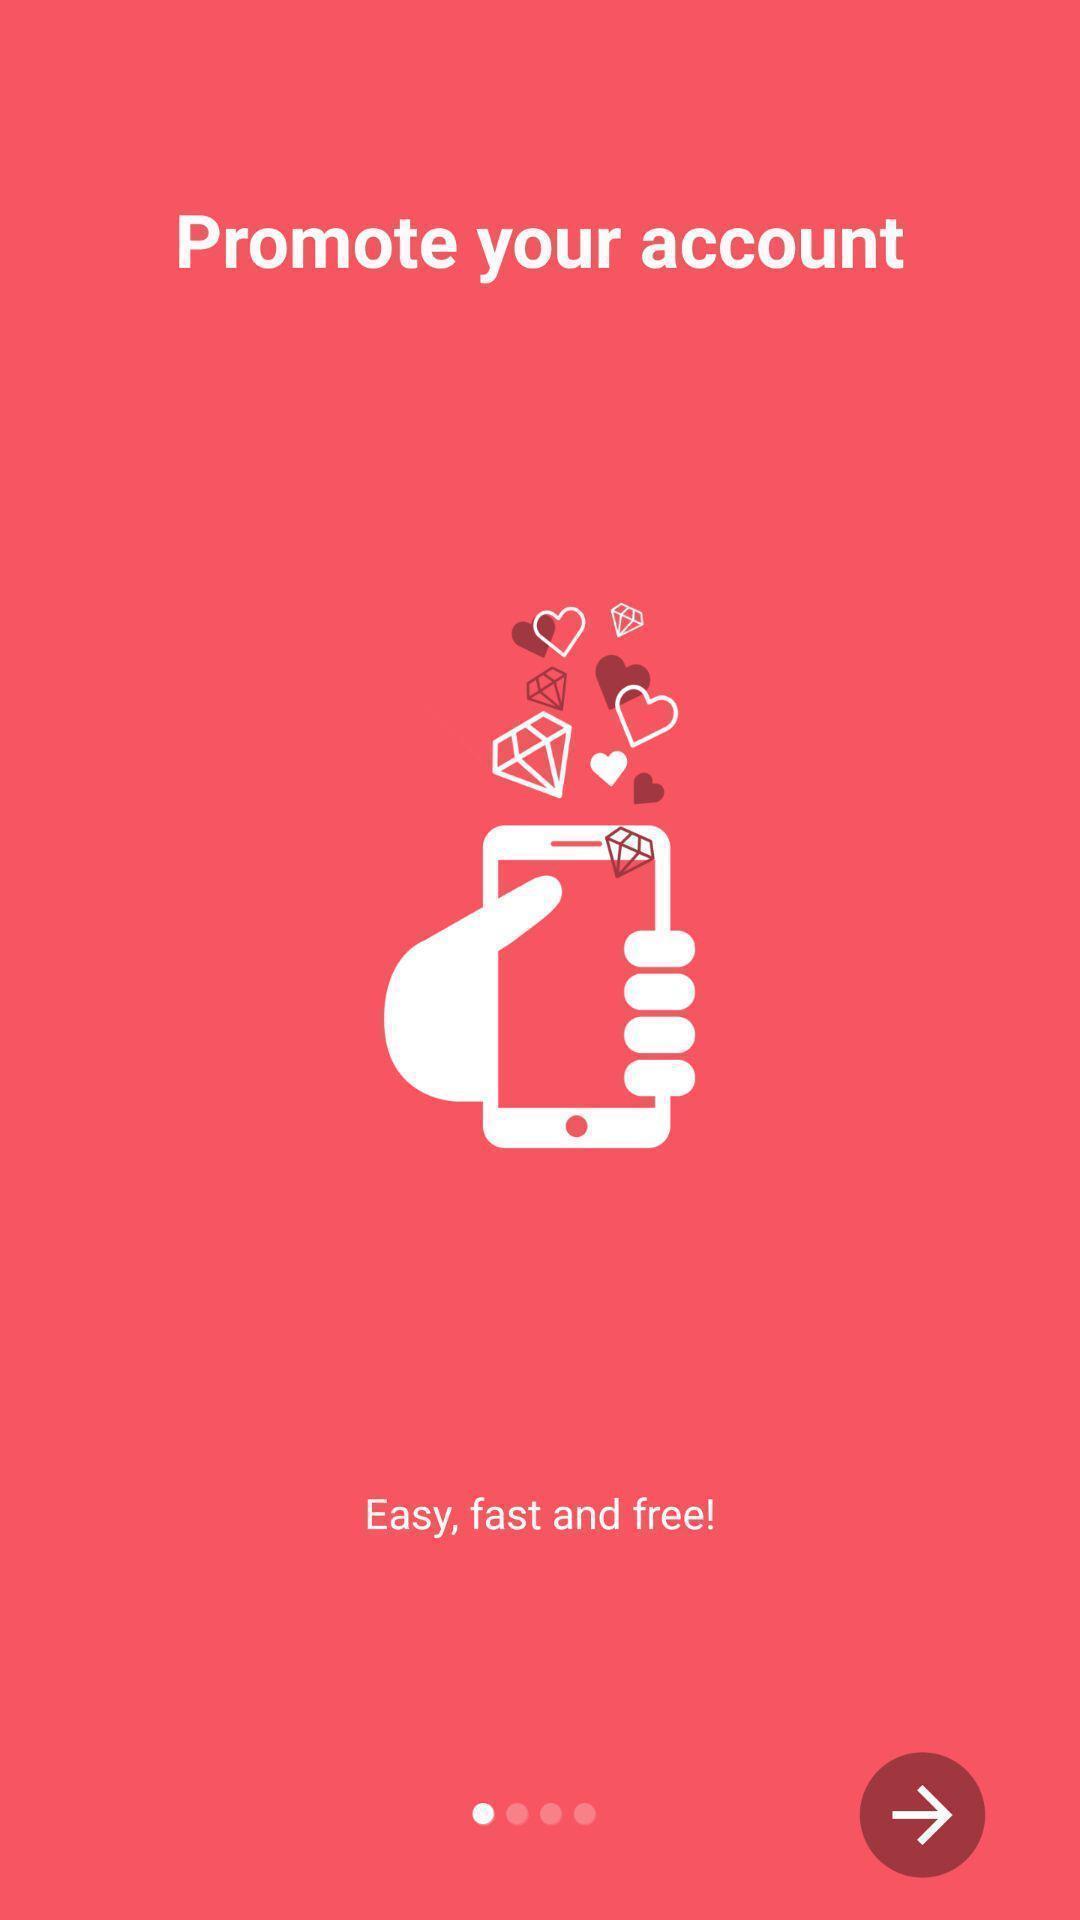Describe the visual elements of this screenshot. Welcome page. 